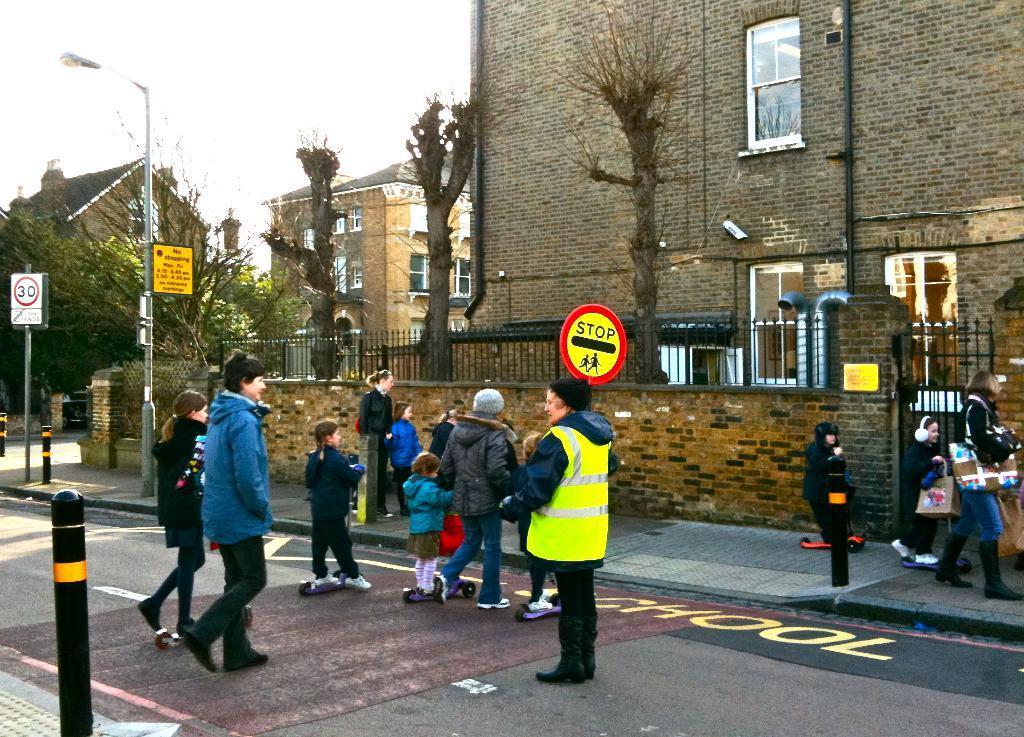How would you summarize this image in a sentence or two? Here few people are crossing the road, a police man is standing he wore a green color coat. Right side it's a building, in the left side there are trees. 